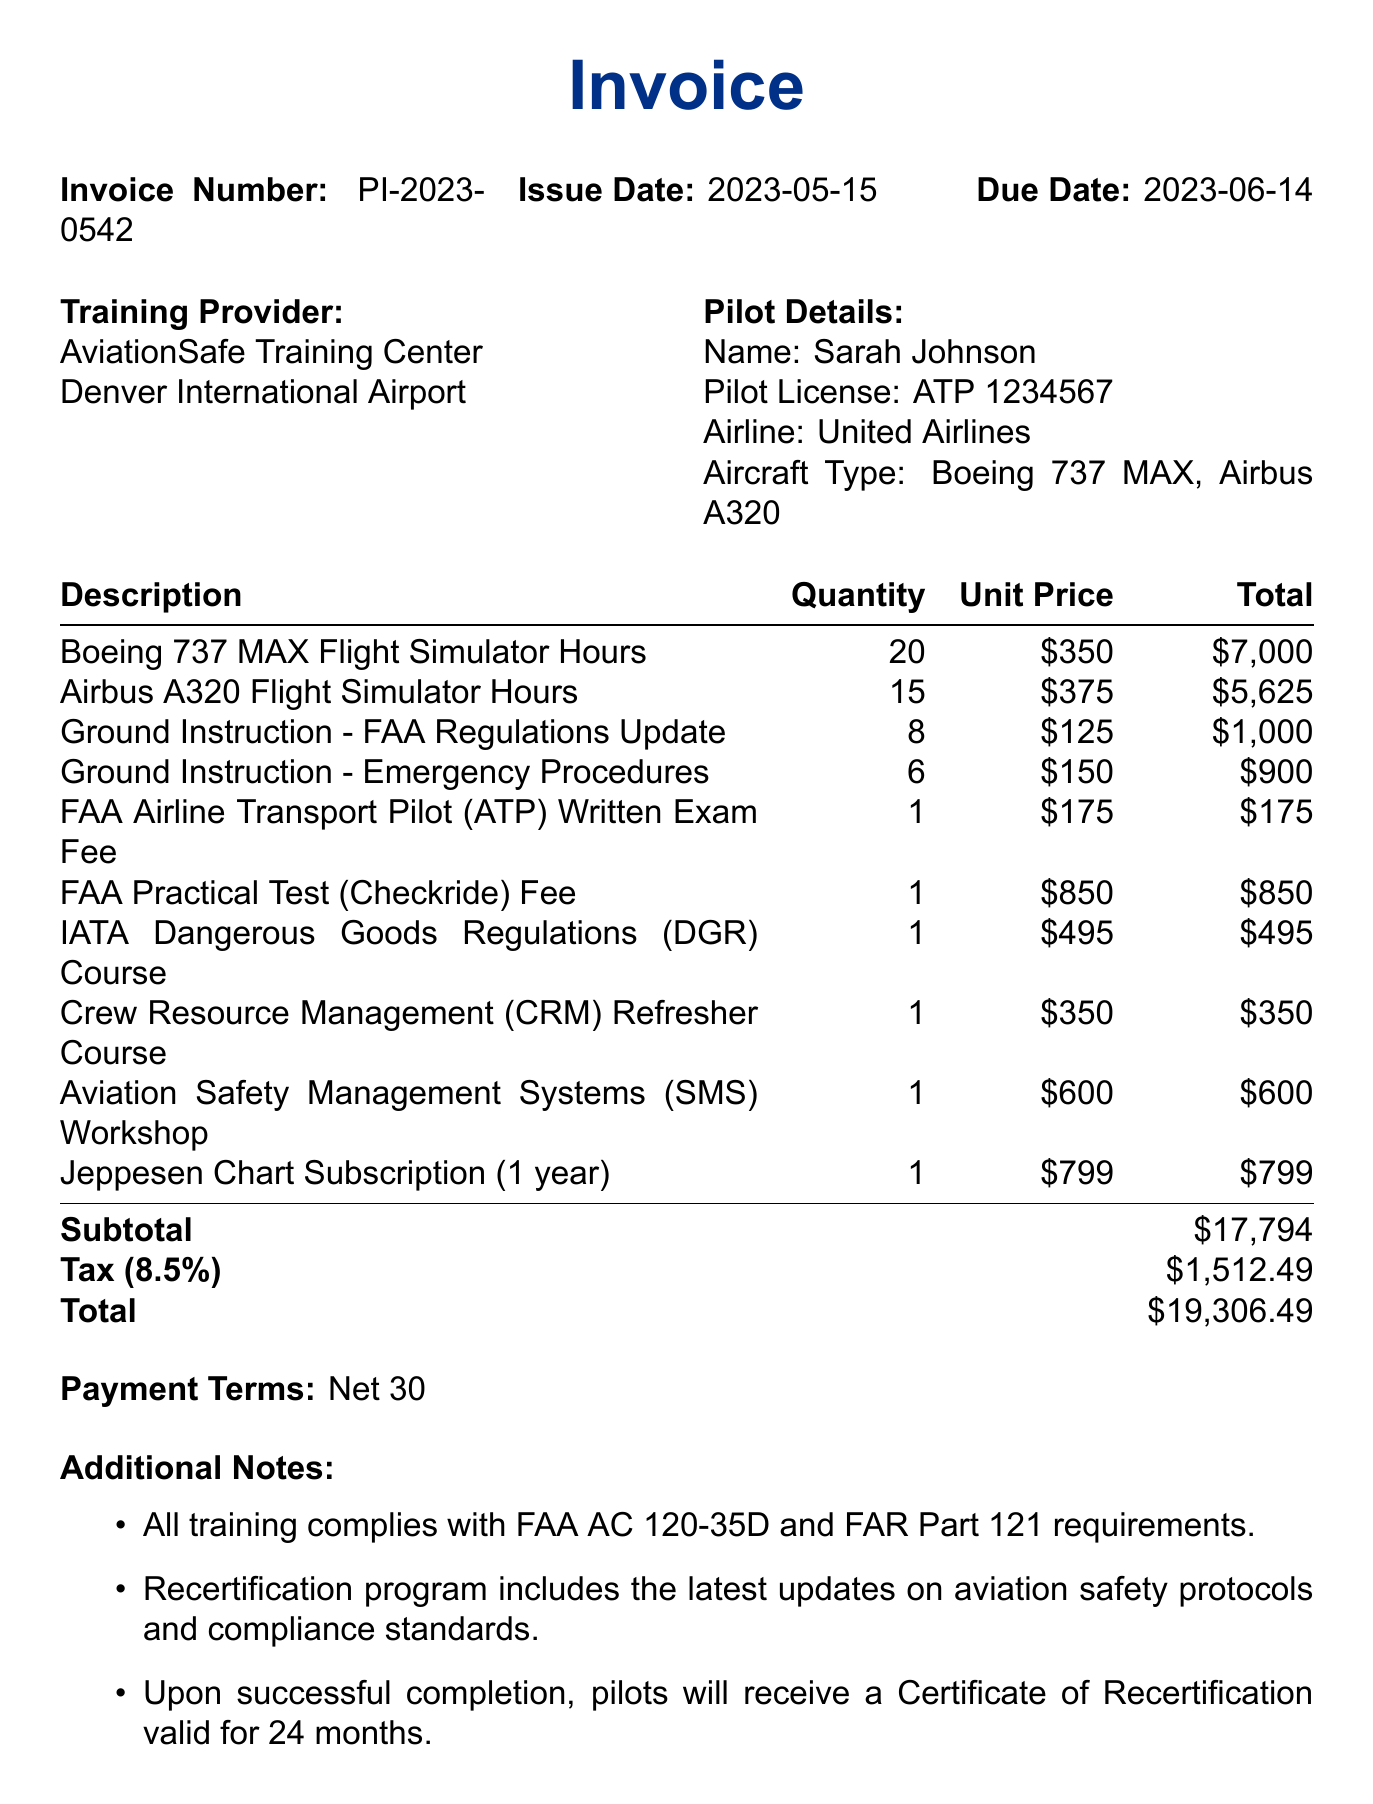What is the invoice number? The invoice number is listed in the document under the invoice details section.
Answer: PI-2023-0542 What is the issue date of the invoice? The issue date is specified in the invoice details section of the document.
Answer: 2023-05-15 How many flight simulator hours are billed for Boeing 737 MAX? The quantity of Boeing 737 MAX flight simulator hours is stated in the invoice items section.
Answer: 20 What is the total price for the Airbus A320 flight simulator hours? The total price for the Airbus A320 flight simulator hours is mentioned in the invoice items.
Answer: 5625 What are the payment terms stated in the invoice? The payment terms are explicitly listed in the invoice details section.
Answer: Net 30 What training complies with FAA AC 120-35D requirements? This is mentioned in the additional notes as a requirement for the training provided.
Answer: All training How many total items are listed on the invoice? The total number of items can be counted in the invoice items section of the document.
Answer: 10 What is the tax rate applied to the invoice? The tax rate is indicated in the invoice details section of the document.
Answer: 8.5 What is included in the recertification program? This information is found in the additional notes, describing the contents of the program.
Answer: Latest updates on aviation safety protocols and compliance standards 